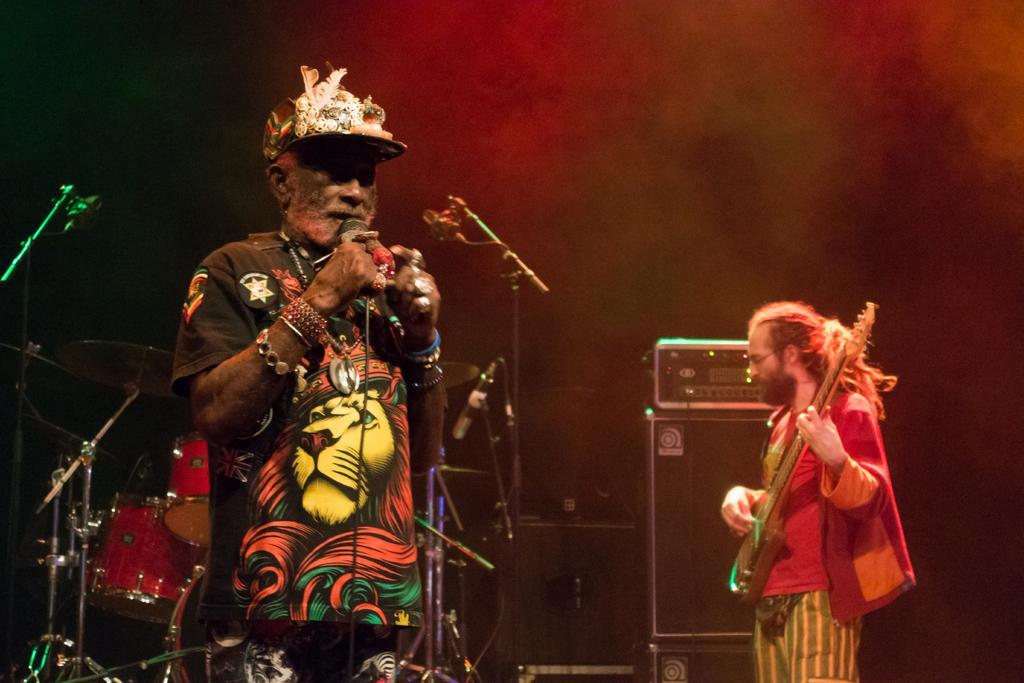Can you describe this image briefly? In this image we can see a person holding a mic. On the right side we can see a person holding a guitar. On the backside we can see some drums and mics with stand. 